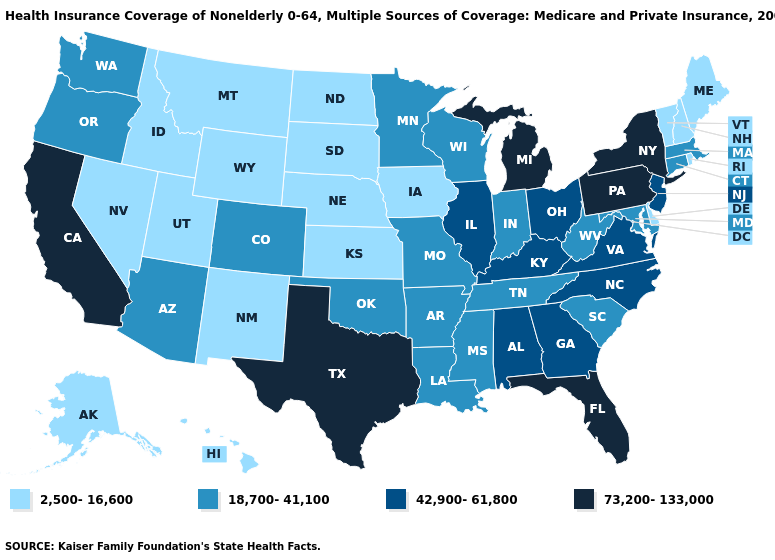Name the states that have a value in the range 18,700-41,100?
Quick response, please. Arizona, Arkansas, Colorado, Connecticut, Indiana, Louisiana, Maryland, Massachusetts, Minnesota, Mississippi, Missouri, Oklahoma, Oregon, South Carolina, Tennessee, Washington, West Virginia, Wisconsin. Does Washington have the same value as South Dakota?
Quick response, please. No. Name the states that have a value in the range 73,200-133,000?
Answer briefly. California, Florida, Michigan, New York, Pennsylvania, Texas. What is the value of Pennsylvania?
Keep it brief. 73,200-133,000. Does the map have missing data?
Short answer required. No. Name the states that have a value in the range 73,200-133,000?
Keep it brief. California, Florida, Michigan, New York, Pennsylvania, Texas. Name the states that have a value in the range 18,700-41,100?
Quick response, please. Arizona, Arkansas, Colorado, Connecticut, Indiana, Louisiana, Maryland, Massachusetts, Minnesota, Mississippi, Missouri, Oklahoma, Oregon, South Carolina, Tennessee, Washington, West Virginia, Wisconsin. Does Texas have the highest value in the USA?
Be succinct. Yes. What is the value of Indiana?
Concise answer only. 18,700-41,100. What is the highest value in states that border Texas?
Short answer required. 18,700-41,100. Which states hav the highest value in the South?
Write a very short answer. Florida, Texas. Does the first symbol in the legend represent the smallest category?
Be succinct. Yes. Among the states that border Kansas , which have the highest value?
Keep it brief. Colorado, Missouri, Oklahoma. Does Indiana have a higher value than South Carolina?
Keep it brief. No. 